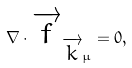<formula> <loc_0><loc_0><loc_500><loc_500>\nabla \cdot \overrightarrow { f } _ { \overrightarrow { k } \mu } = 0 ,</formula> 